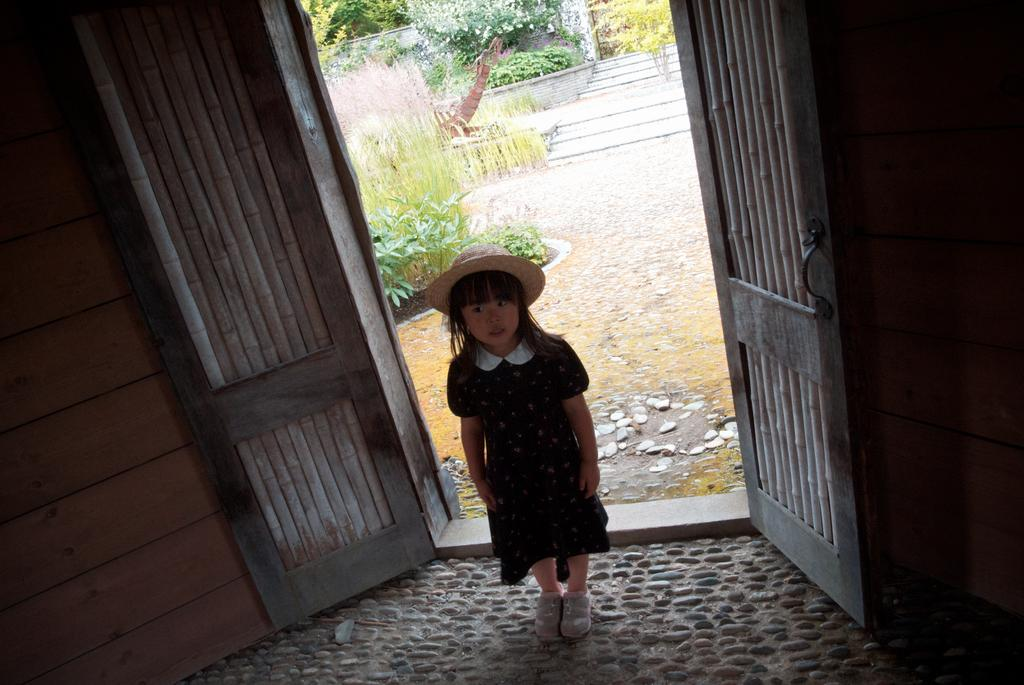Who is the main subject in the image? There is a girl in the middle of the image. What is the girl wearing? The girl is wearing a dress and a hat. What is the setting of the image? The image features a floor, doors, plants, stones, a staircase, trees, and a wall in the middle of the image. What type of writing can be seen on the girl's dress in the image? There is no writing visible on the girl's dress in the image. Is the girl on vacation in the image? The image does not provide any information about the girl's location or whether she is on vacation. Is the girl standing on an island in the image? There is no indication of an island in the image; it features a floor, doors, plants, stones, a staircase, trees, and a wall in the middle of the image. 